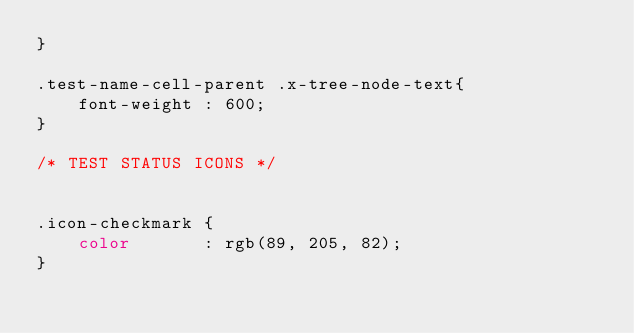Convert code to text. <code><loc_0><loc_0><loc_500><loc_500><_CSS_>}

.test-name-cell-parent .x-tree-node-text{
    font-weight : 600;
}

/* TEST STATUS ICONS */


.icon-checkmark {
    color       : rgb(89, 205, 82);
}



</code> 